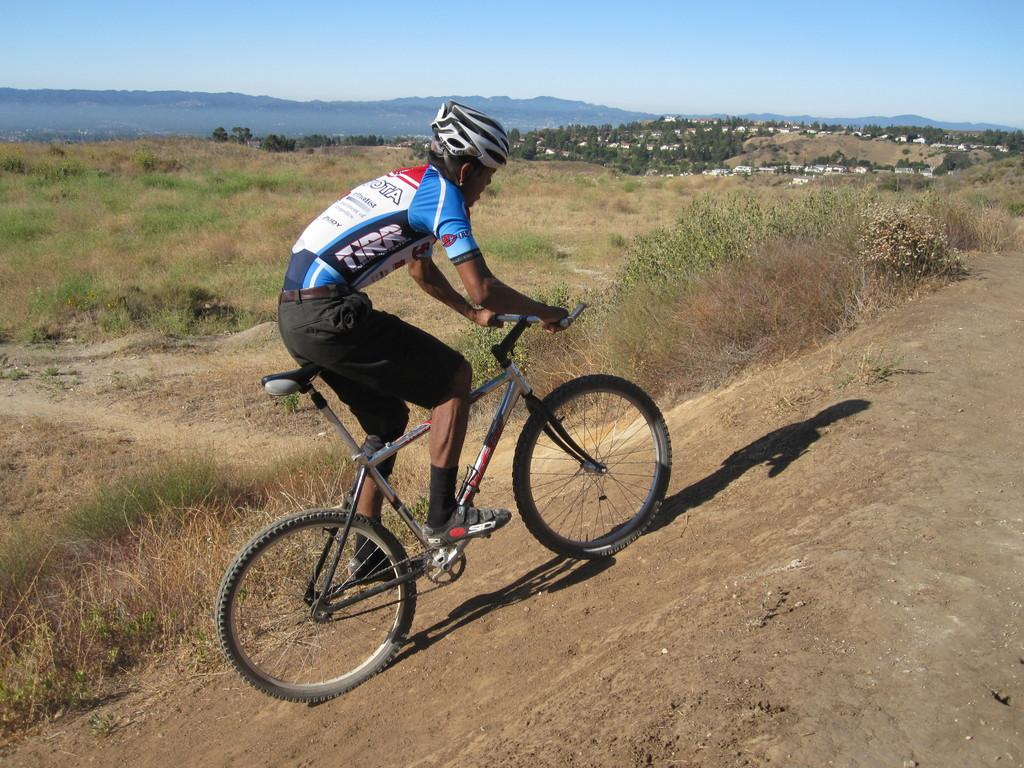What type of living organisms can be seen in the image? Plants can be seen in the image. What is the person in the image doing? The person is riding a bicycle. What is visible at the top of the image? The sky is visible at the top of the image. What type of dinner is the person eating while riding the bicycle in the image? There is no dinner present in the image, as the person is riding a bicycle and not eating. What is the relationship between the wrist and the bicycle in the image? There is no mention of a wrist or any interaction with the bicycle in the image. 